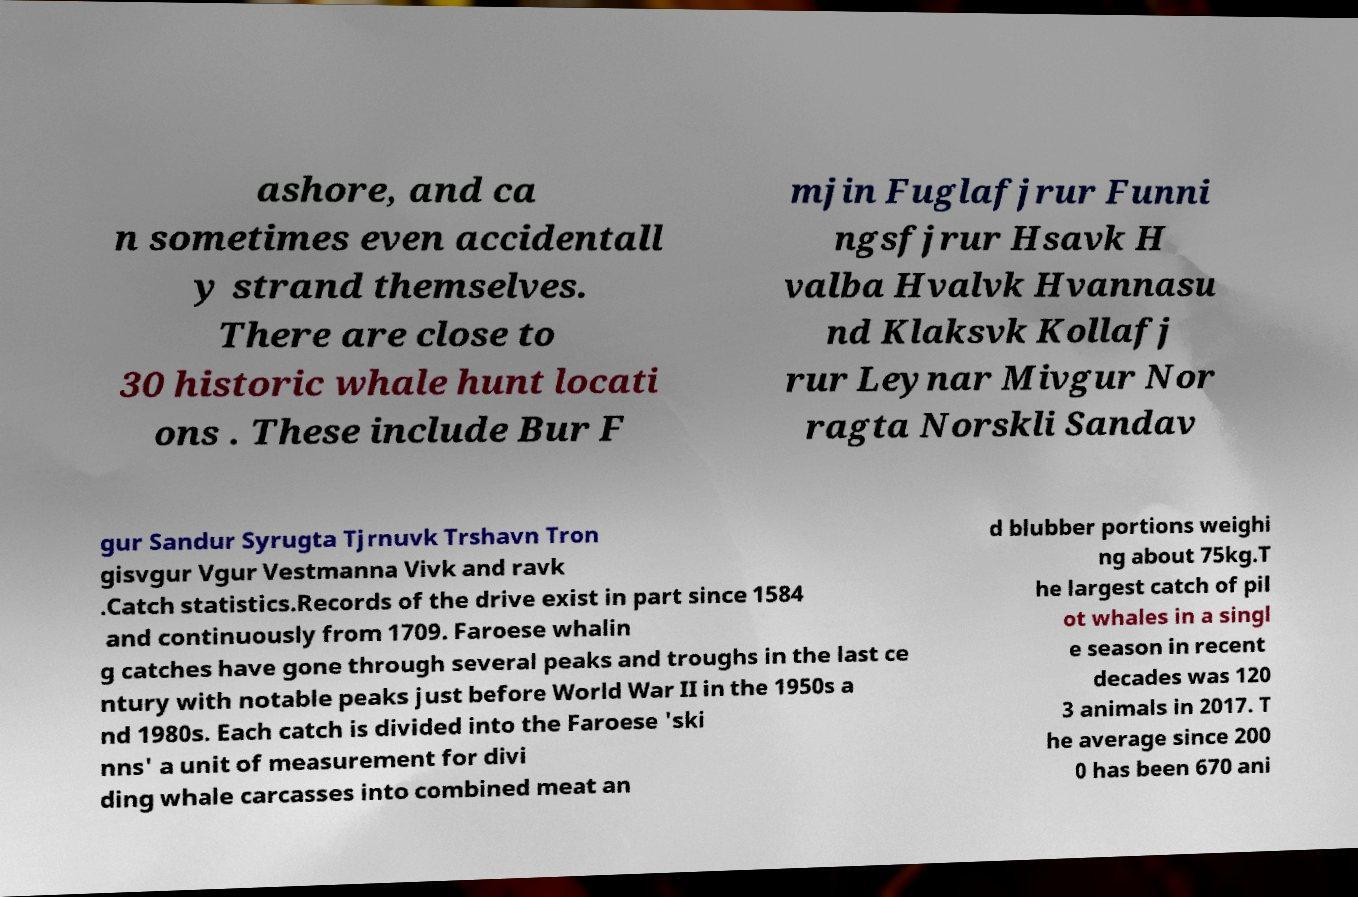I need the written content from this picture converted into text. Can you do that? ashore, and ca n sometimes even accidentall y strand themselves. There are close to 30 historic whale hunt locati ons . These include Bur F mjin Fuglafjrur Funni ngsfjrur Hsavk H valba Hvalvk Hvannasu nd Klaksvk Kollafj rur Leynar Mivgur Nor ragta Norskli Sandav gur Sandur Syrugta Tjrnuvk Trshavn Tron gisvgur Vgur Vestmanna Vivk and ravk .Catch statistics.Records of the drive exist in part since 1584 and continuously from 1709. Faroese whalin g catches have gone through several peaks and troughs in the last ce ntury with notable peaks just before World War II in the 1950s a nd 1980s. Each catch is divided into the Faroese 'ski nns' a unit of measurement for divi ding whale carcasses into combined meat an d blubber portions weighi ng about 75kg.T he largest catch of pil ot whales in a singl e season in recent decades was 120 3 animals in 2017. T he average since 200 0 has been 670 ani 